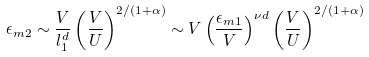Convert formula to latex. <formula><loc_0><loc_0><loc_500><loc_500>\epsilon _ { m 2 } \sim \frac { V } { l _ { 1 } ^ { d } } \left ( \frac { V } { U } \right ) ^ { 2 / ( 1 + \alpha ) } \sim V \left ( \frac { \epsilon _ { m 1 } } { V } \right ) ^ { \nu d } \left ( \frac { V } { U } \right ) ^ { 2 / ( 1 + \alpha ) }</formula> 